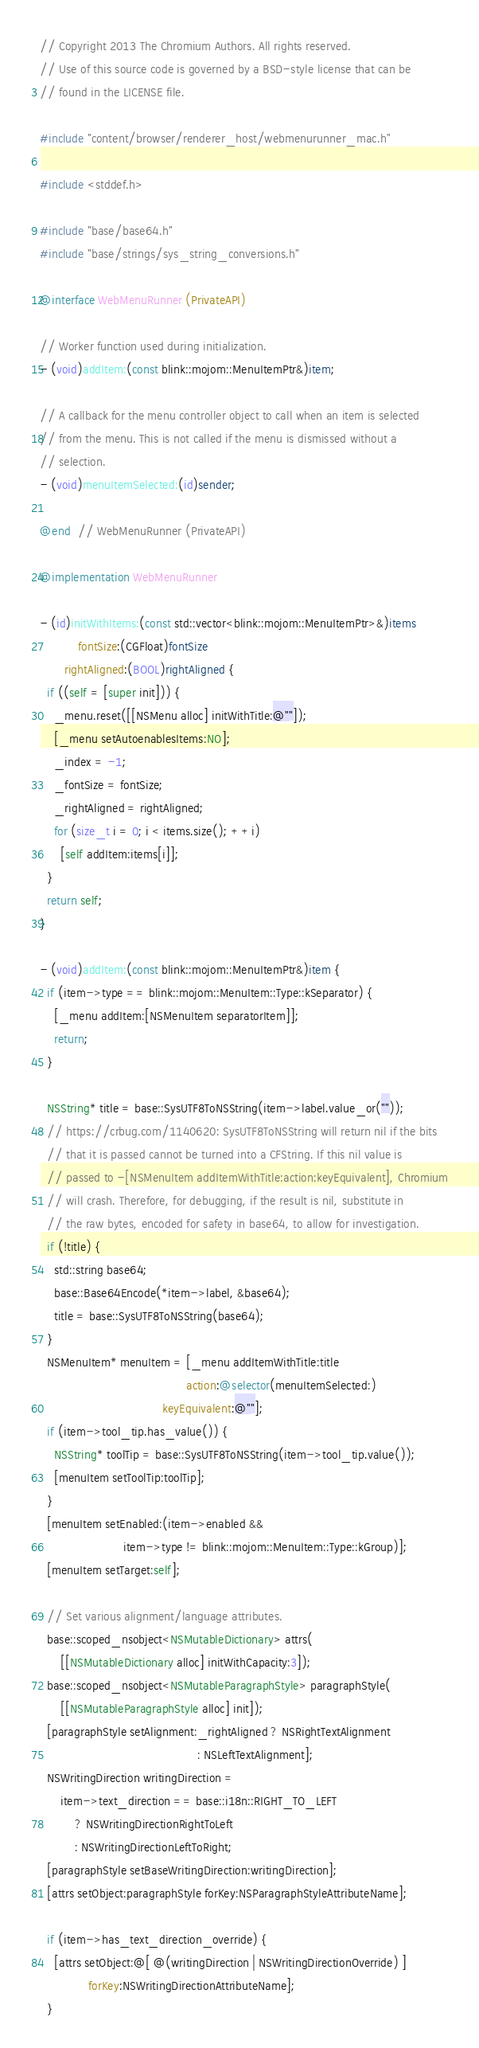Convert code to text. <code><loc_0><loc_0><loc_500><loc_500><_ObjectiveC_>// Copyright 2013 The Chromium Authors. All rights reserved.
// Use of this source code is governed by a BSD-style license that can be
// found in the LICENSE file.

#include "content/browser/renderer_host/webmenurunner_mac.h"

#include <stddef.h>

#include "base/base64.h"
#include "base/strings/sys_string_conversions.h"

@interface WebMenuRunner (PrivateAPI)

// Worker function used during initialization.
- (void)addItem:(const blink::mojom::MenuItemPtr&)item;

// A callback for the menu controller object to call when an item is selected
// from the menu. This is not called if the menu is dismissed without a
// selection.
- (void)menuItemSelected:(id)sender;

@end  // WebMenuRunner (PrivateAPI)

@implementation WebMenuRunner

- (id)initWithItems:(const std::vector<blink::mojom::MenuItemPtr>&)items
           fontSize:(CGFloat)fontSize
       rightAligned:(BOOL)rightAligned {
  if ((self = [super init])) {
    _menu.reset([[NSMenu alloc] initWithTitle:@""]);
    [_menu setAutoenablesItems:NO];
    _index = -1;
    _fontSize = fontSize;
    _rightAligned = rightAligned;
    for (size_t i = 0; i < items.size(); ++i)
      [self addItem:items[i]];
  }
  return self;
}

- (void)addItem:(const blink::mojom::MenuItemPtr&)item {
  if (item->type == blink::mojom::MenuItem::Type::kSeparator) {
    [_menu addItem:[NSMenuItem separatorItem]];
    return;
  }

  NSString* title = base::SysUTF8ToNSString(item->label.value_or(""));
  // https://crbug.com/1140620: SysUTF8ToNSString will return nil if the bits
  // that it is passed cannot be turned into a CFString. If this nil value is
  // passed to -[NSMenuItem addItemWithTitle:action:keyEquivalent], Chromium
  // will crash. Therefore, for debugging, if the result is nil, substitute in
  // the raw bytes, encoded for safety in base64, to allow for investigation.
  if (!title) {
    std::string base64;
    base::Base64Encode(*item->label, &base64);
    title = base::SysUTF8ToNSString(base64);
  }
  NSMenuItem* menuItem = [_menu addItemWithTitle:title
                                          action:@selector(menuItemSelected:)
                                   keyEquivalent:@""];
  if (item->tool_tip.has_value()) {
    NSString* toolTip = base::SysUTF8ToNSString(item->tool_tip.value());
    [menuItem setToolTip:toolTip];
  }
  [menuItem setEnabled:(item->enabled &&
                        item->type != blink::mojom::MenuItem::Type::kGroup)];
  [menuItem setTarget:self];

  // Set various alignment/language attributes.
  base::scoped_nsobject<NSMutableDictionary> attrs(
      [[NSMutableDictionary alloc] initWithCapacity:3]);
  base::scoped_nsobject<NSMutableParagraphStyle> paragraphStyle(
      [[NSMutableParagraphStyle alloc] init]);
  [paragraphStyle setAlignment:_rightAligned ? NSRightTextAlignment
                                             : NSLeftTextAlignment];
  NSWritingDirection writingDirection =
      item->text_direction == base::i18n::RIGHT_TO_LEFT
          ? NSWritingDirectionRightToLeft
          : NSWritingDirectionLeftToRight;
  [paragraphStyle setBaseWritingDirection:writingDirection];
  [attrs setObject:paragraphStyle forKey:NSParagraphStyleAttributeName];

  if (item->has_text_direction_override) {
    [attrs setObject:@[ @(writingDirection | NSWritingDirectionOverride) ]
              forKey:NSWritingDirectionAttributeName];
  }
</code> 